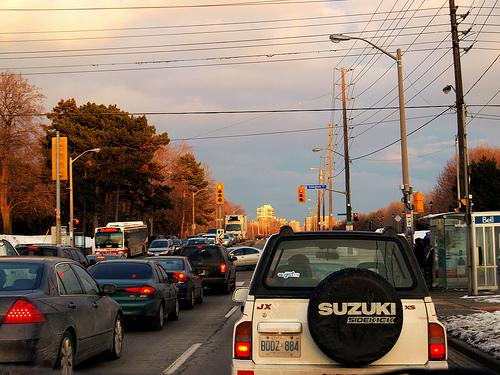Question: why are the cars stopped?
Choices:
A. The road is blocked.
B. The light is yellow.
C. The police say to.
D. The light is red.
Answer with the letter. Answer: D Question: where is the photo taken?
Choices:
A. A forest.
B. A beach.
C. A meadow.
D. A city street.
Answer with the letter. Answer: D Question: what are the cars doing?
Choices:
A. Going through a red light.
B. Going through a green light.
C. Stopping at a green light.
D. Stopping at a red light.
Answer with the letter. Answer: D 